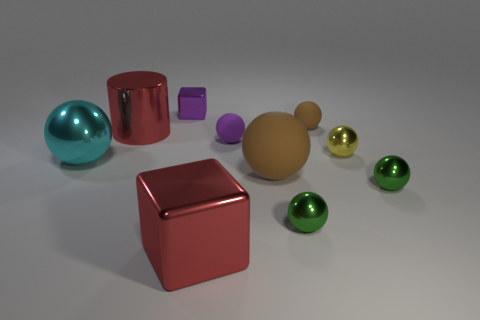Subtract all purple matte balls. How many balls are left? 6 Subtract all cyan balls. How many balls are left? 6 Subtract all yellow balls. Subtract all green cylinders. How many balls are left? 6 Subtract all cylinders. How many objects are left? 9 Add 7 purple metallic objects. How many purple metallic objects are left? 8 Add 2 purple blocks. How many purple blocks exist? 3 Subtract 2 green balls. How many objects are left? 8 Subtract all green shiny things. Subtract all large cyan objects. How many objects are left? 7 